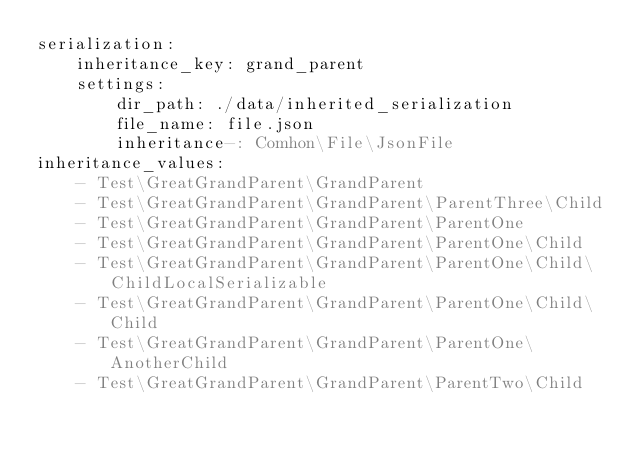Convert code to text. <code><loc_0><loc_0><loc_500><loc_500><_YAML_>serialization:
    inheritance_key: grand_parent
    settings:
        dir_path: ./data/inherited_serialization
        file_name: file.json
        inheritance-: Comhon\File\JsonFile
inheritance_values:
    - Test\GreatGrandParent\GrandParent
    - Test\GreatGrandParent\GrandParent\ParentThree\Child
    - Test\GreatGrandParent\GrandParent\ParentOne
    - Test\GreatGrandParent\GrandParent\ParentOne\Child
    - Test\GreatGrandParent\GrandParent\ParentOne\Child\ChildLocalSerializable
    - Test\GreatGrandParent\GrandParent\ParentOne\Child\Child
    - Test\GreatGrandParent\GrandParent\ParentOne\AnotherChild
    - Test\GreatGrandParent\GrandParent\ParentTwo\Child
</code> 